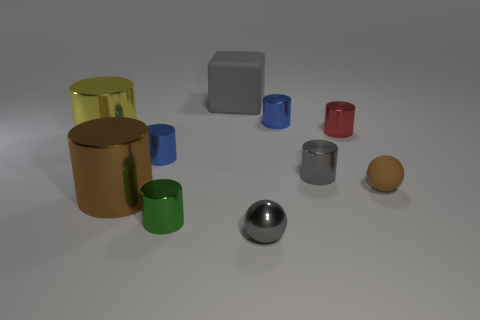Is the number of big yellow metal cylinders in front of the small green cylinder the same as the number of small red objects that are right of the red shiny thing?
Offer a very short reply. Yes. Are there any yellow cylinders that have the same size as the gray matte thing?
Your answer should be very brief. Yes. What is the size of the yellow cylinder?
Your answer should be compact. Large. Are there the same number of small metallic spheres in front of the gray rubber block and metallic spheres?
Give a very brief answer. Yes. How many other things are there of the same color as the tiny matte ball?
Provide a succinct answer. 1. There is a small object that is both in front of the large yellow object and on the right side of the gray cylinder; what color is it?
Make the answer very short. Brown. There is a brown thing that is left of the sphere in front of the ball that is behind the tiny gray sphere; how big is it?
Your response must be concise. Large. What number of objects are either things to the left of the tiny red metallic cylinder or small objects that are behind the tiny red object?
Make the answer very short. 8. The small brown object is what shape?
Offer a very short reply. Sphere. What number of other objects are there of the same material as the small brown sphere?
Your answer should be very brief. 1. 